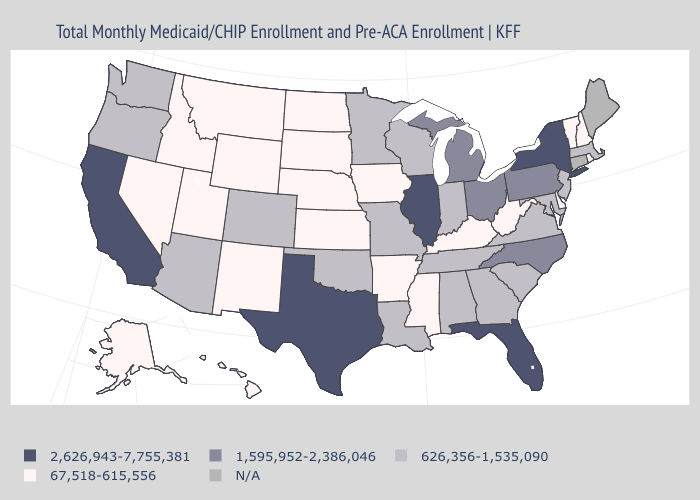What is the lowest value in the MidWest?
Quick response, please. 67,518-615,556. Name the states that have a value in the range N/A?
Write a very short answer. Connecticut, Maine. Which states have the highest value in the USA?
Short answer required. California, Florida, Illinois, New York, Texas. Name the states that have a value in the range 67,518-615,556?
Short answer required. Alaska, Arkansas, Delaware, Hawaii, Idaho, Iowa, Kansas, Kentucky, Mississippi, Montana, Nebraska, Nevada, New Hampshire, New Mexico, North Dakota, Rhode Island, South Dakota, Utah, Vermont, West Virginia, Wyoming. Which states have the lowest value in the MidWest?
Answer briefly. Iowa, Kansas, Nebraska, North Dakota, South Dakota. Which states hav the highest value in the South?
Write a very short answer. Florida, Texas. Is the legend a continuous bar?
Short answer required. No. Name the states that have a value in the range 1,595,952-2,386,046?
Short answer required. Michigan, North Carolina, Ohio, Pennsylvania. What is the value of Georgia?
Quick response, please. 626,356-1,535,090. Name the states that have a value in the range 67,518-615,556?
Write a very short answer. Alaska, Arkansas, Delaware, Hawaii, Idaho, Iowa, Kansas, Kentucky, Mississippi, Montana, Nebraska, Nevada, New Hampshire, New Mexico, North Dakota, Rhode Island, South Dakota, Utah, Vermont, West Virginia, Wyoming. What is the value of South Dakota?
Concise answer only. 67,518-615,556. Name the states that have a value in the range 2,626,943-7,755,381?
Concise answer only. California, Florida, Illinois, New York, Texas. Among the states that border Oklahoma , does Arkansas have the highest value?
Quick response, please. No. Which states have the highest value in the USA?
Concise answer only. California, Florida, Illinois, New York, Texas. 